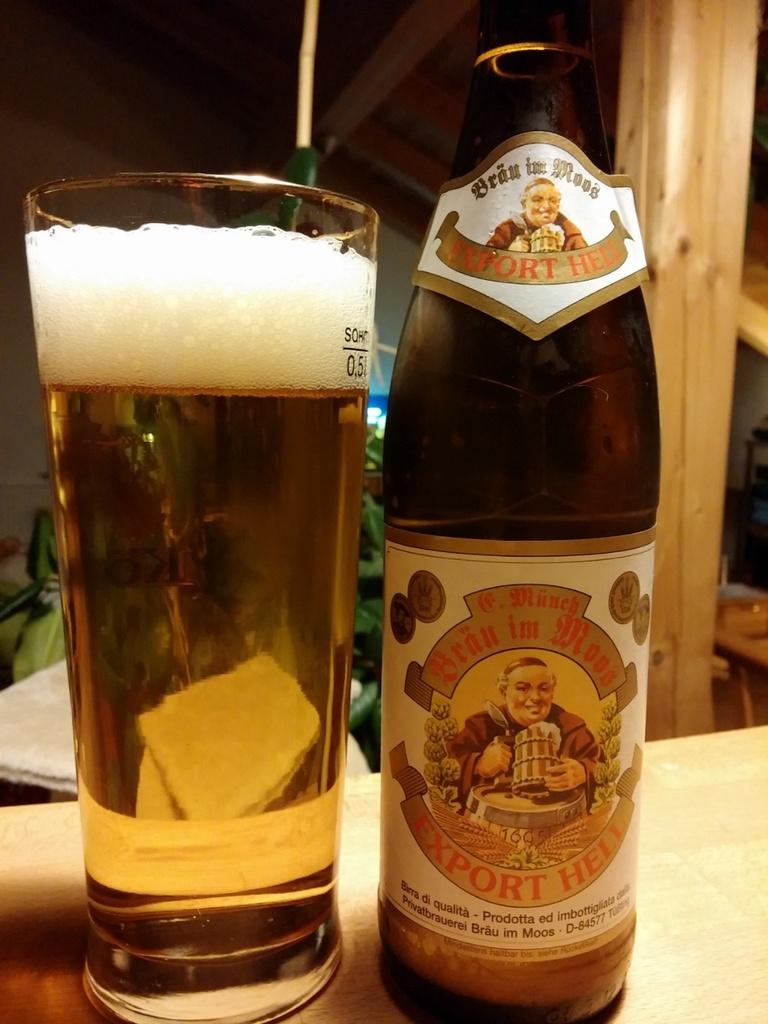What is the name of this beer?
Give a very brief answer. Export hell. 